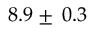<formula> <loc_0><loc_0><loc_500><loc_500>8 . 9 \pm \, 0 . 3</formula> 